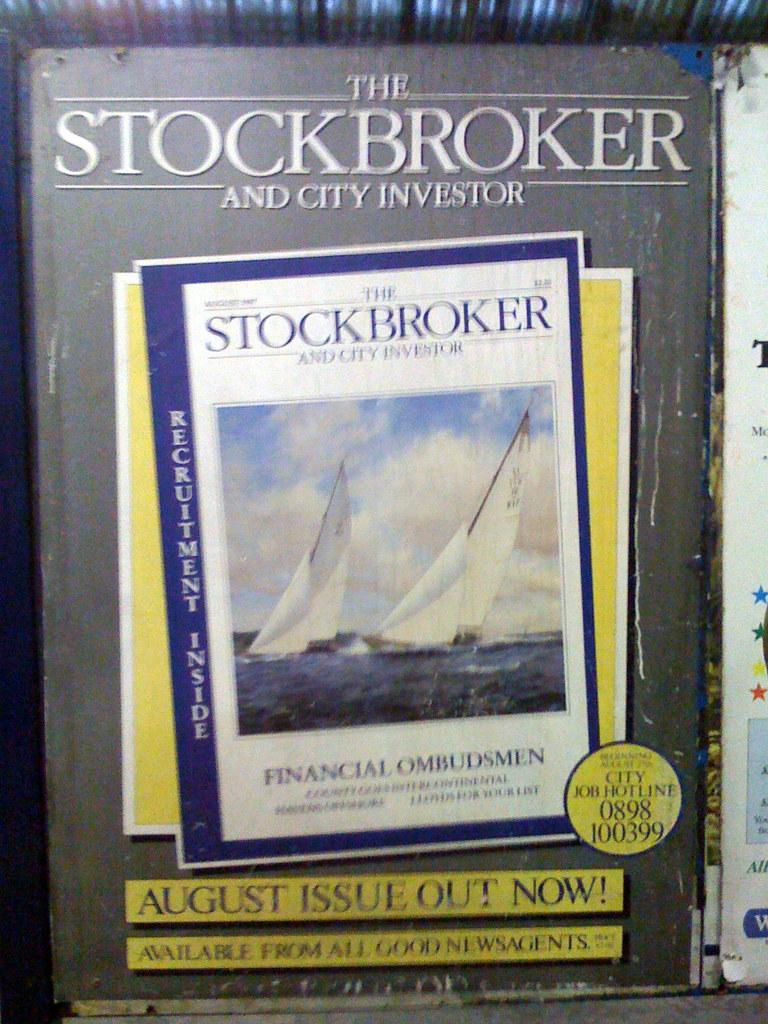<image>
Give a short and clear explanation of the subsequent image. The Stockbroker and City Investor magazine says that the August issue is out now. 